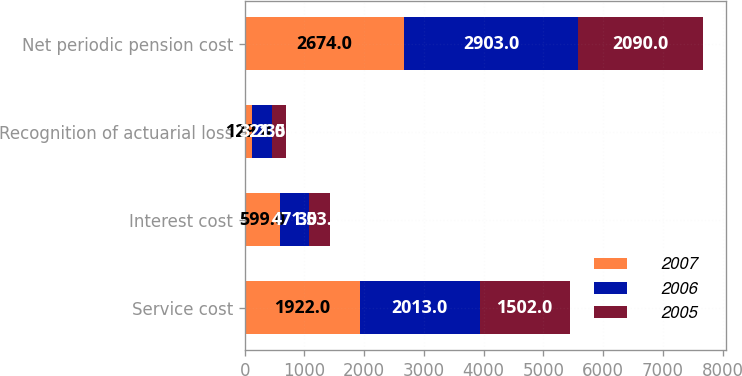Convert chart to OTSL. <chart><loc_0><loc_0><loc_500><loc_500><stacked_bar_chart><ecel><fcel>Service cost<fcel>Interest cost<fcel>Recognition of actuarial loss<fcel>Net periodic pension cost<nl><fcel>2007<fcel>1922<fcel>599<fcel>129<fcel>2674<nl><fcel>2006<fcel>2013<fcel>471<fcel>321<fcel>2903<nl><fcel>2005<fcel>1502<fcel>353<fcel>235<fcel>2090<nl></chart> 